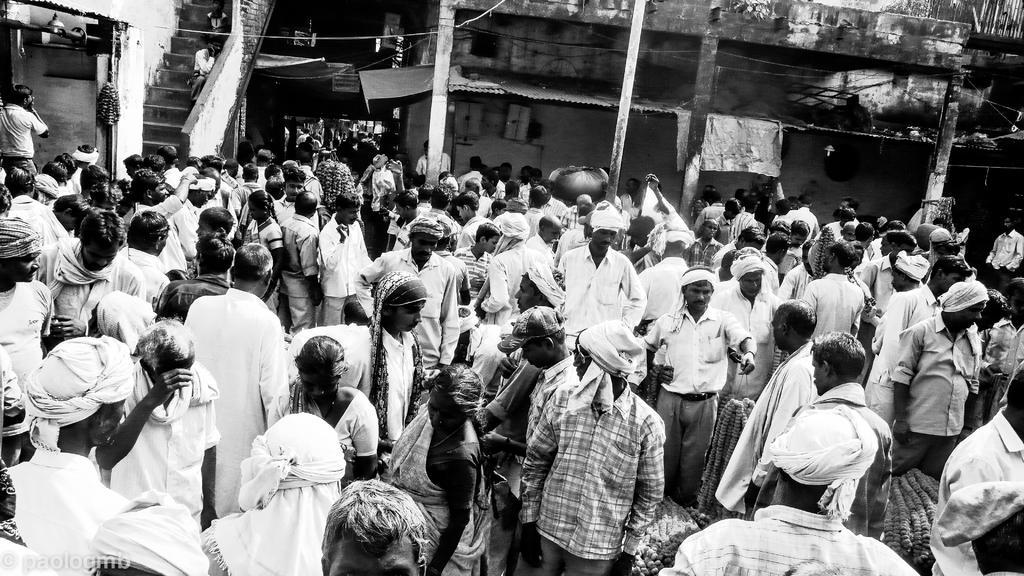Please provide a concise description of this image. In this picture there are persons standing. In the background there are buildings and there are steps. 